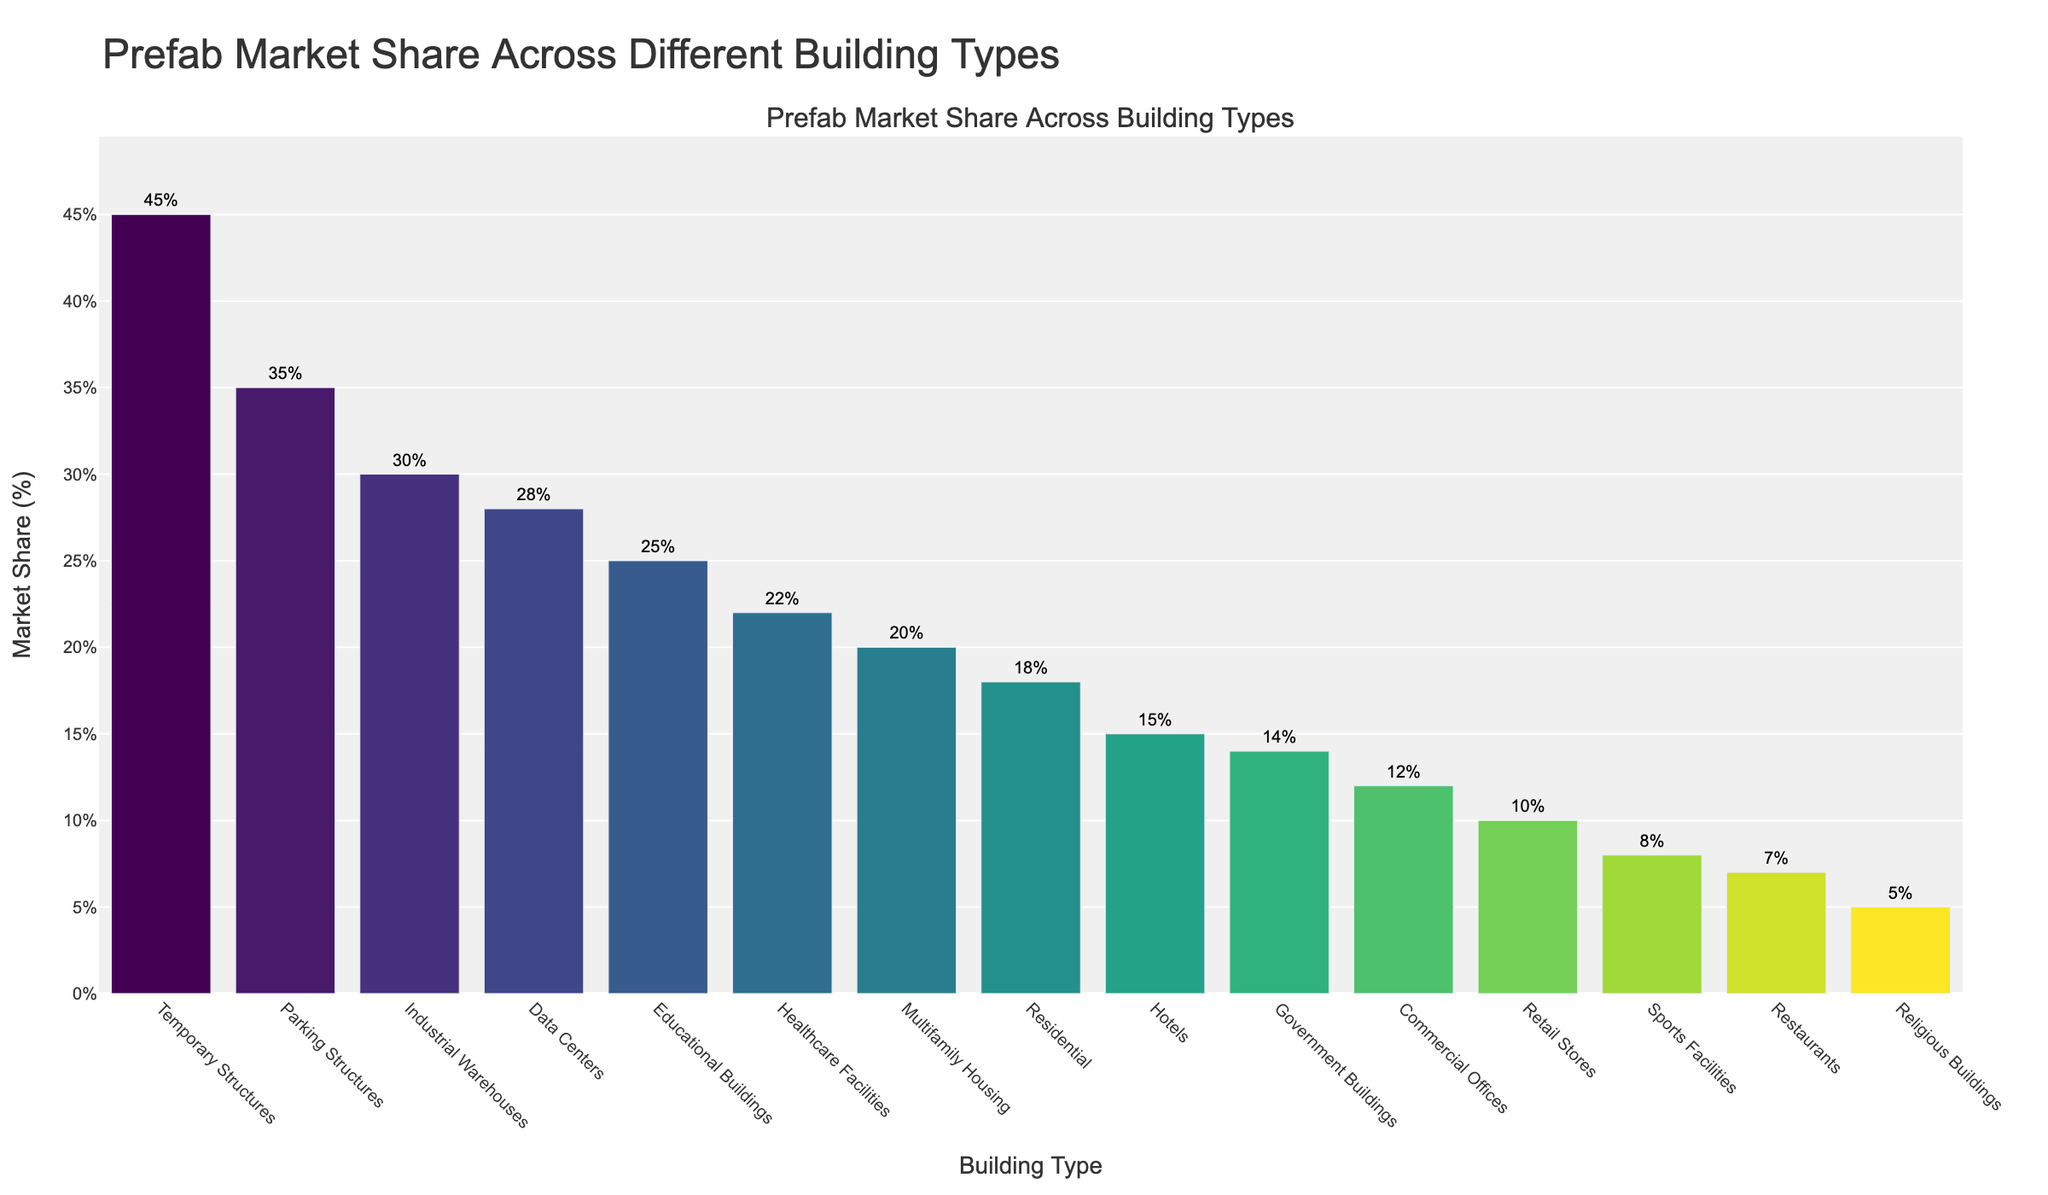What are the three building types with the highest prefab market share? Look at the three tallest bars in the figure, which are highlighted with rectangles. These correspond to Temporary Structures, Parking Structures, and Industrial Warehouses.
Answer: Temporary Structures, Parking Structures, Industrial Warehouses Which building type has the lowest prefab market share? Identify the shortest bar in the figure to find the building type with the lowest market share, which is Religious Buildings.
Answer: Religious Buildings What is the difference in prefab market share between Residential buildings and Commercial Offices? Find the bars for Residential and Commercial Offices. Residential has a market share of 18%, and Commercial Offices have 12%. The difference is 18% - 12% = 6%.
Answer: 6% How many building types have a prefab market share greater than 20%? Count the bars that exceed the 20% mark. These are Healthcare Facilities, Educational Buildings, Industrial Warehouses, Data Centers, Temporary Structures, and Parking Structures. There are 6 building types in total.
Answer: 6 What is the average prefab market share of Hotels, Healthcare Facilities, and Educational Buildings? Add the market shares for these buildings: 15% (Hotels), 22% (Healthcare Facilities), and 25% (Educational Buildings). The sum is 62%. Divide by the number of buildings: 62% / 3 = 20.67%.
Answer: 20.67% What building type has a higher prefab market share: Restaurants or Retail Stores? Compare the heights of the bars for Restaurants and Retail Stores. Retail Stores have a higher prefab market share at 10%, while Restaurants have 7%.
Answer: Retail Stores What is the combined prefab market share of Government Buildings and Sports Facilities? Add the market shares of Government Buildings (14%) and Sports Facilities (8%). The combined share is 14% + 8% = 22%.
Answer: 22% Which building type, among those shown, is the fourth highest in prefab market share? Identify the fourth tallest bar in the figure. The fourth highest is Data Centers with a market share of 28%.
Answer: Data Centers Are more building types below 15% or above 25% in prefab market share? Count the bars below 15% (Commercial Offices, Retail Stores, Sports Facilities, Religious Buildings, Restaurants) which is 5, and those above 25% (Educational Buildings, Industrial Warehouses, Data Centers, Temporary Structures, Parking Structures) which is also 5. Both counts are equal.
Answer: Equal 